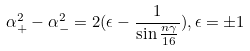Convert formula to latex. <formula><loc_0><loc_0><loc_500><loc_500>\alpha _ { + } ^ { 2 } - \alpha _ { - } ^ { 2 } = 2 ( \epsilon - \frac { 1 } { \sin \frac { n \gamma } { 1 6 } } ) , \epsilon = \pm 1</formula> 